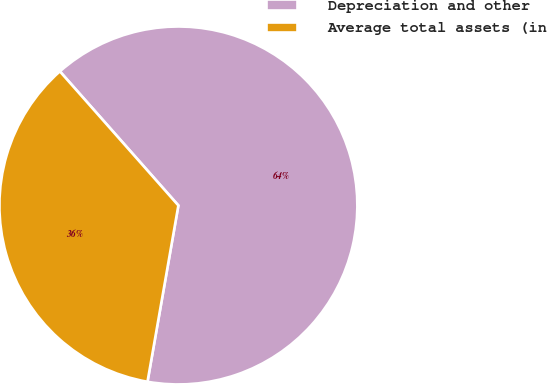Convert chart to OTSL. <chart><loc_0><loc_0><loc_500><loc_500><pie_chart><fcel>Depreciation and other<fcel>Average total assets (in<nl><fcel>64.28%<fcel>35.72%<nl></chart> 